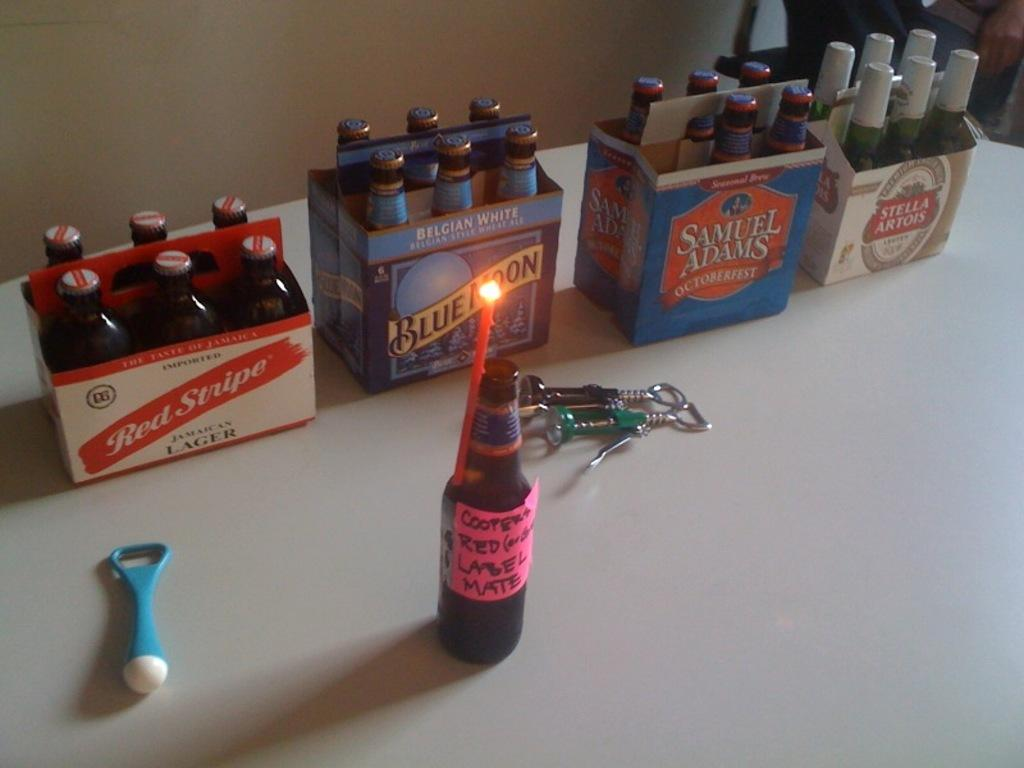<image>
Provide a brief description of the given image. A line of six packs of beer on a table and a single bottle labeled red label mate. 